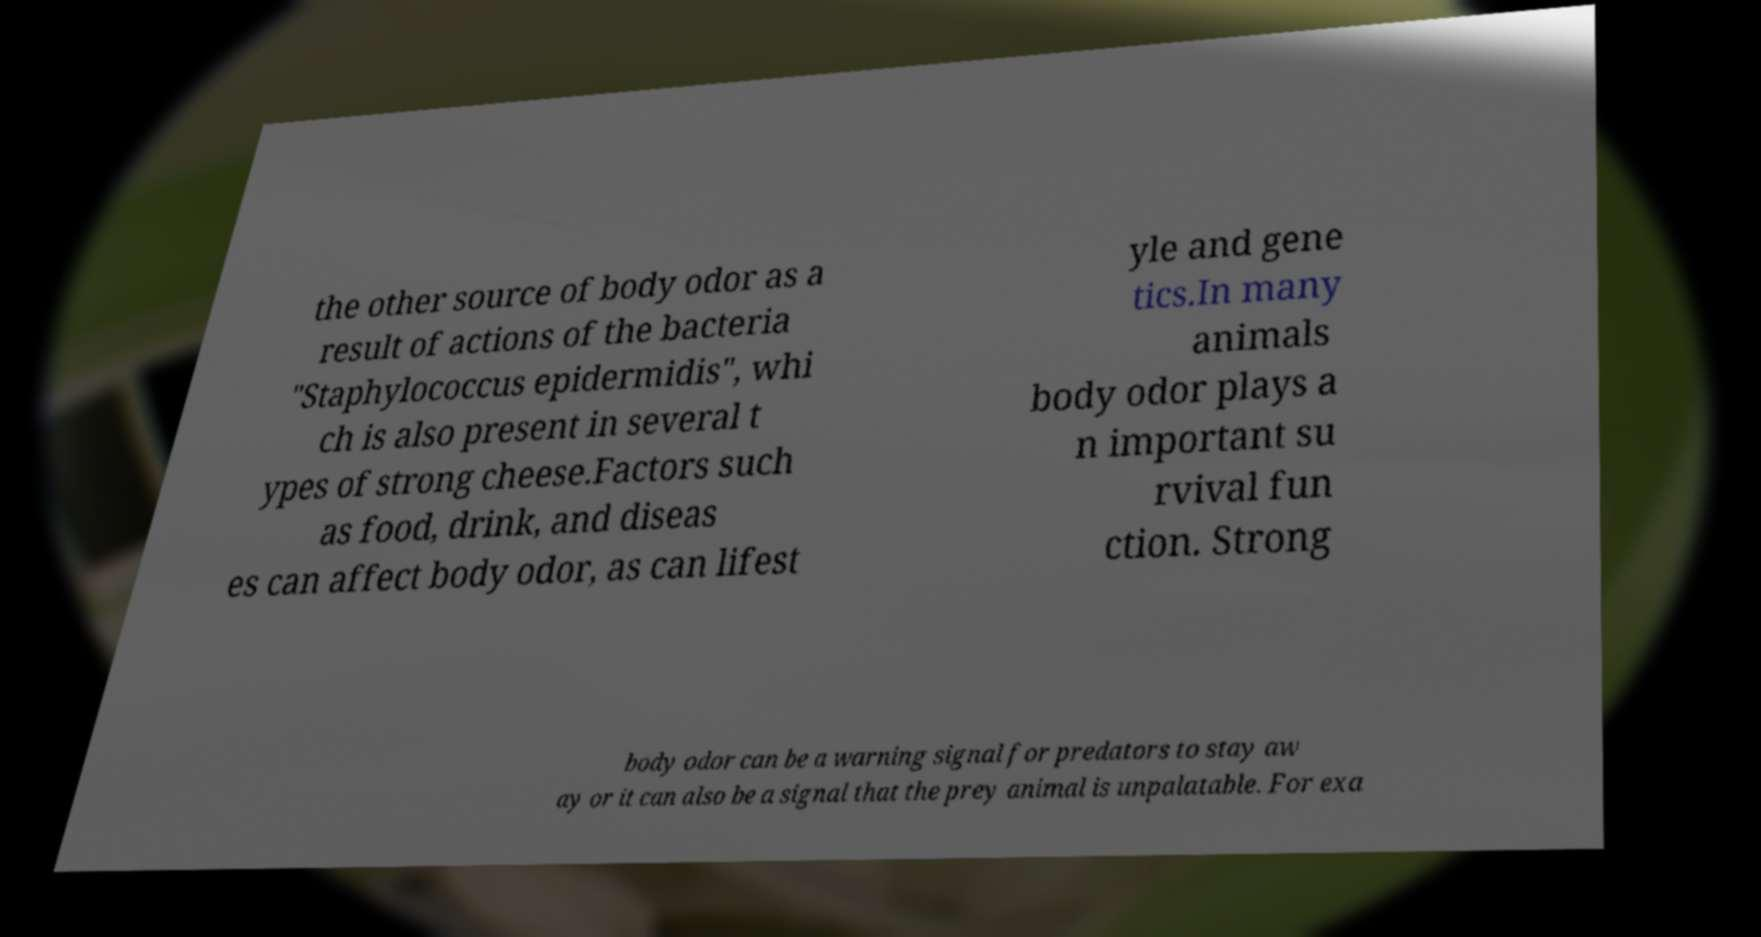Can you read and provide the text displayed in the image?This photo seems to have some interesting text. Can you extract and type it out for me? the other source of body odor as a result of actions of the bacteria "Staphylococcus epidermidis", whi ch is also present in several t ypes of strong cheese.Factors such as food, drink, and diseas es can affect body odor, as can lifest yle and gene tics.In many animals body odor plays a n important su rvival fun ction. Strong body odor can be a warning signal for predators to stay aw ay or it can also be a signal that the prey animal is unpalatable. For exa 